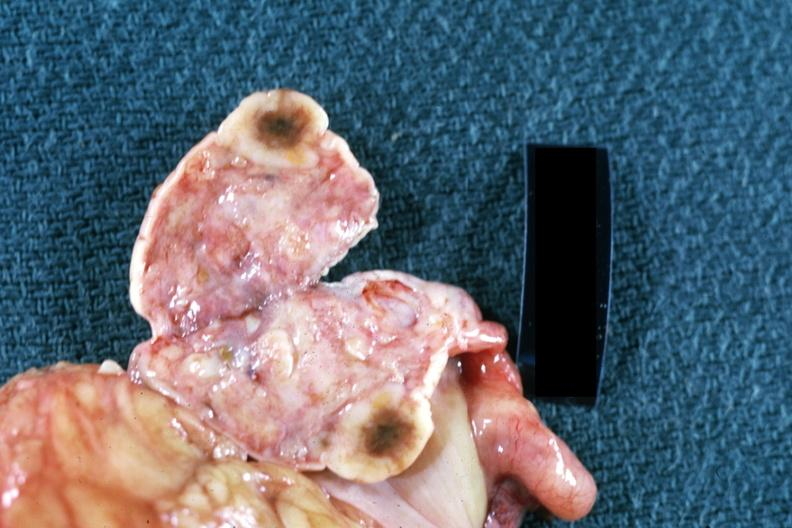s coronary artery present?
Answer the question using a single word or phrase. No 